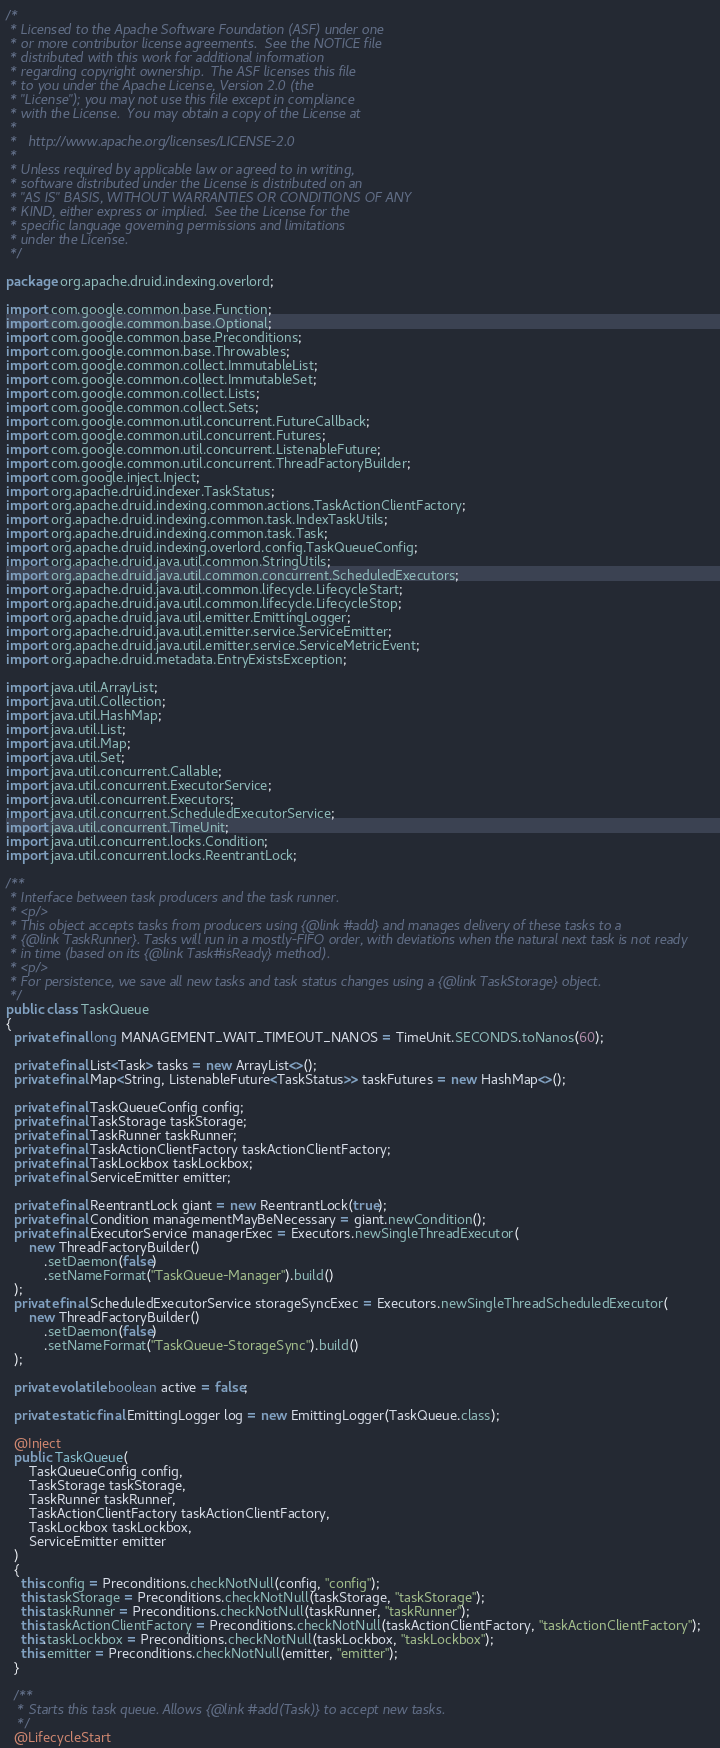<code> <loc_0><loc_0><loc_500><loc_500><_Java_>/*
 * Licensed to the Apache Software Foundation (ASF) under one
 * or more contributor license agreements.  See the NOTICE file
 * distributed with this work for additional information
 * regarding copyright ownership.  The ASF licenses this file
 * to you under the Apache License, Version 2.0 (the
 * "License"); you may not use this file except in compliance
 * with the License.  You may obtain a copy of the License at
 *
 *   http://www.apache.org/licenses/LICENSE-2.0
 *
 * Unless required by applicable law or agreed to in writing,
 * software distributed under the License is distributed on an
 * "AS IS" BASIS, WITHOUT WARRANTIES OR CONDITIONS OF ANY
 * KIND, either express or implied.  See the License for the
 * specific language governing permissions and limitations
 * under the License.
 */

package org.apache.druid.indexing.overlord;

import com.google.common.base.Function;
import com.google.common.base.Optional;
import com.google.common.base.Preconditions;
import com.google.common.base.Throwables;
import com.google.common.collect.ImmutableList;
import com.google.common.collect.ImmutableSet;
import com.google.common.collect.Lists;
import com.google.common.collect.Sets;
import com.google.common.util.concurrent.FutureCallback;
import com.google.common.util.concurrent.Futures;
import com.google.common.util.concurrent.ListenableFuture;
import com.google.common.util.concurrent.ThreadFactoryBuilder;
import com.google.inject.Inject;
import org.apache.druid.indexer.TaskStatus;
import org.apache.druid.indexing.common.actions.TaskActionClientFactory;
import org.apache.druid.indexing.common.task.IndexTaskUtils;
import org.apache.druid.indexing.common.task.Task;
import org.apache.druid.indexing.overlord.config.TaskQueueConfig;
import org.apache.druid.java.util.common.StringUtils;
import org.apache.druid.java.util.common.concurrent.ScheduledExecutors;
import org.apache.druid.java.util.common.lifecycle.LifecycleStart;
import org.apache.druid.java.util.common.lifecycle.LifecycleStop;
import org.apache.druid.java.util.emitter.EmittingLogger;
import org.apache.druid.java.util.emitter.service.ServiceEmitter;
import org.apache.druid.java.util.emitter.service.ServiceMetricEvent;
import org.apache.druid.metadata.EntryExistsException;

import java.util.ArrayList;
import java.util.Collection;
import java.util.HashMap;
import java.util.List;
import java.util.Map;
import java.util.Set;
import java.util.concurrent.Callable;
import java.util.concurrent.ExecutorService;
import java.util.concurrent.Executors;
import java.util.concurrent.ScheduledExecutorService;
import java.util.concurrent.TimeUnit;
import java.util.concurrent.locks.Condition;
import java.util.concurrent.locks.ReentrantLock;

/**
 * Interface between task producers and the task runner.
 * <p/>
 * This object accepts tasks from producers using {@link #add} and manages delivery of these tasks to a
 * {@link TaskRunner}. Tasks will run in a mostly-FIFO order, with deviations when the natural next task is not ready
 * in time (based on its {@link Task#isReady} method).
 * <p/>
 * For persistence, we save all new tasks and task status changes using a {@link TaskStorage} object.
 */
public class TaskQueue
{
  private final long MANAGEMENT_WAIT_TIMEOUT_NANOS = TimeUnit.SECONDS.toNanos(60);

  private final List<Task> tasks = new ArrayList<>();
  private final Map<String, ListenableFuture<TaskStatus>> taskFutures = new HashMap<>();

  private final TaskQueueConfig config;
  private final TaskStorage taskStorage;
  private final TaskRunner taskRunner;
  private final TaskActionClientFactory taskActionClientFactory;
  private final TaskLockbox taskLockbox;
  private final ServiceEmitter emitter;

  private final ReentrantLock giant = new ReentrantLock(true);
  private final Condition managementMayBeNecessary = giant.newCondition();
  private final ExecutorService managerExec = Executors.newSingleThreadExecutor(
      new ThreadFactoryBuilder()
          .setDaemon(false)
          .setNameFormat("TaskQueue-Manager").build()
  );
  private final ScheduledExecutorService storageSyncExec = Executors.newSingleThreadScheduledExecutor(
      new ThreadFactoryBuilder()
          .setDaemon(false)
          .setNameFormat("TaskQueue-StorageSync").build()
  );

  private volatile boolean active = false;

  private static final EmittingLogger log = new EmittingLogger(TaskQueue.class);

  @Inject
  public TaskQueue(
      TaskQueueConfig config,
      TaskStorage taskStorage,
      TaskRunner taskRunner,
      TaskActionClientFactory taskActionClientFactory,
      TaskLockbox taskLockbox,
      ServiceEmitter emitter
  )
  {
    this.config = Preconditions.checkNotNull(config, "config");
    this.taskStorage = Preconditions.checkNotNull(taskStorage, "taskStorage");
    this.taskRunner = Preconditions.checkNotNull(taskRunner, "taskRunner");
    this.taskActionClientFactory = Preconditions.checkNotNull(taskActionClientFactory, "taskActionClientFactory");
    this.taskLockbox = Preconditions.checkNotNull(taskLockbox, "taskLockbox");
    this.emitter = Preconditions.checkNotNull(emitter, "emitter");
  }

  /**
   * Starts this task queue. Allows {@link #add(Task)} to accept new tasks.
   */
  @LifecycleStart</code> 